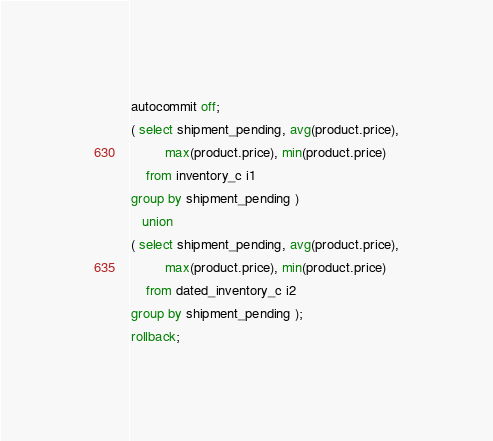<code> <loc_0><loc_0><loc_500><loc_500><_SQL_>autocommit off;
( select shipment_pending, avg(product.price),
         max(product.price), min(product.price)
    from inventory_c i1
group by shipment_pending )
   union
( select shipment_pending, avg(product.price),
         max(product.price), min(product.price)
    from dated_inventory_c i2
group by shipment_pending );
rollback;
</code> 